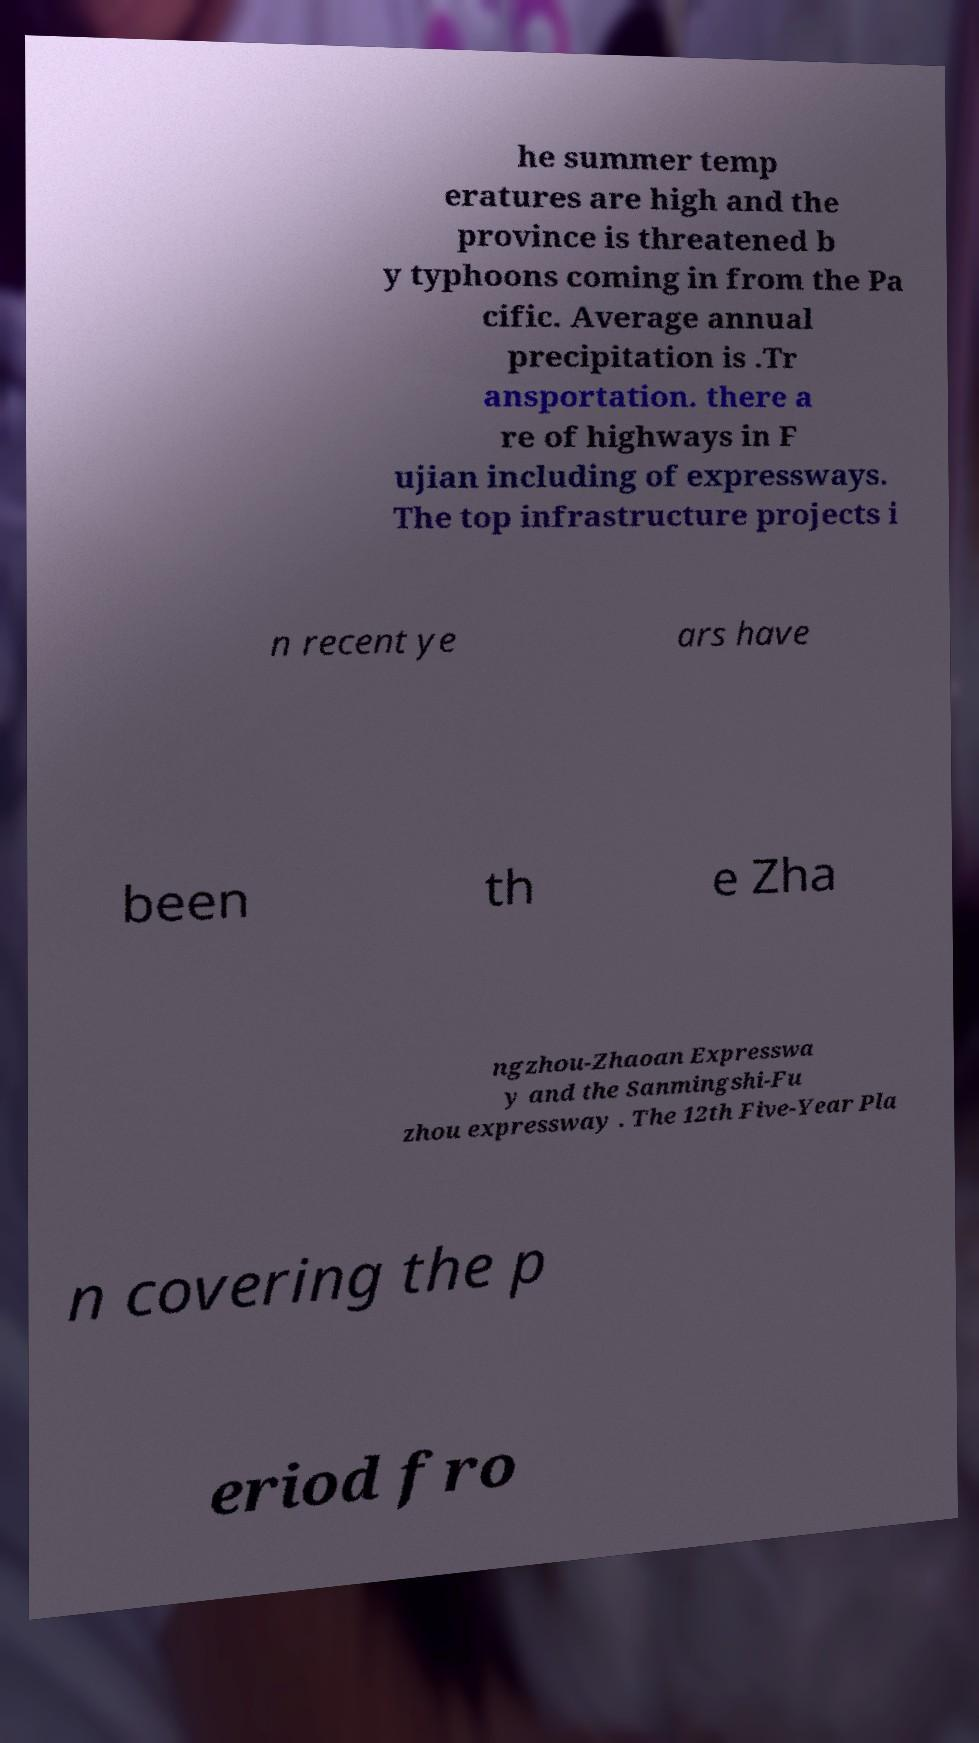Please read and relay the text visible in this image. What does it say? he summer temp eratures are high and the province is threatened b y typhoons coming in from the Pa cific. Average annual precipitation is .Tr ansportation. there a re of highways in F ujian including of expressways. The top infrastructure projects i n recent ye ars have been th e Zha ngzhou-Zhaoan Expresswa y and the Sanmingshi-Fu zhou expressway . The 12th Five-Year Pla n covering the p eriod fro 